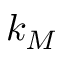Convert formula to latex. <formula><loc_0><loc_0><loc_500><loc_500>k _ { M }</formula> 